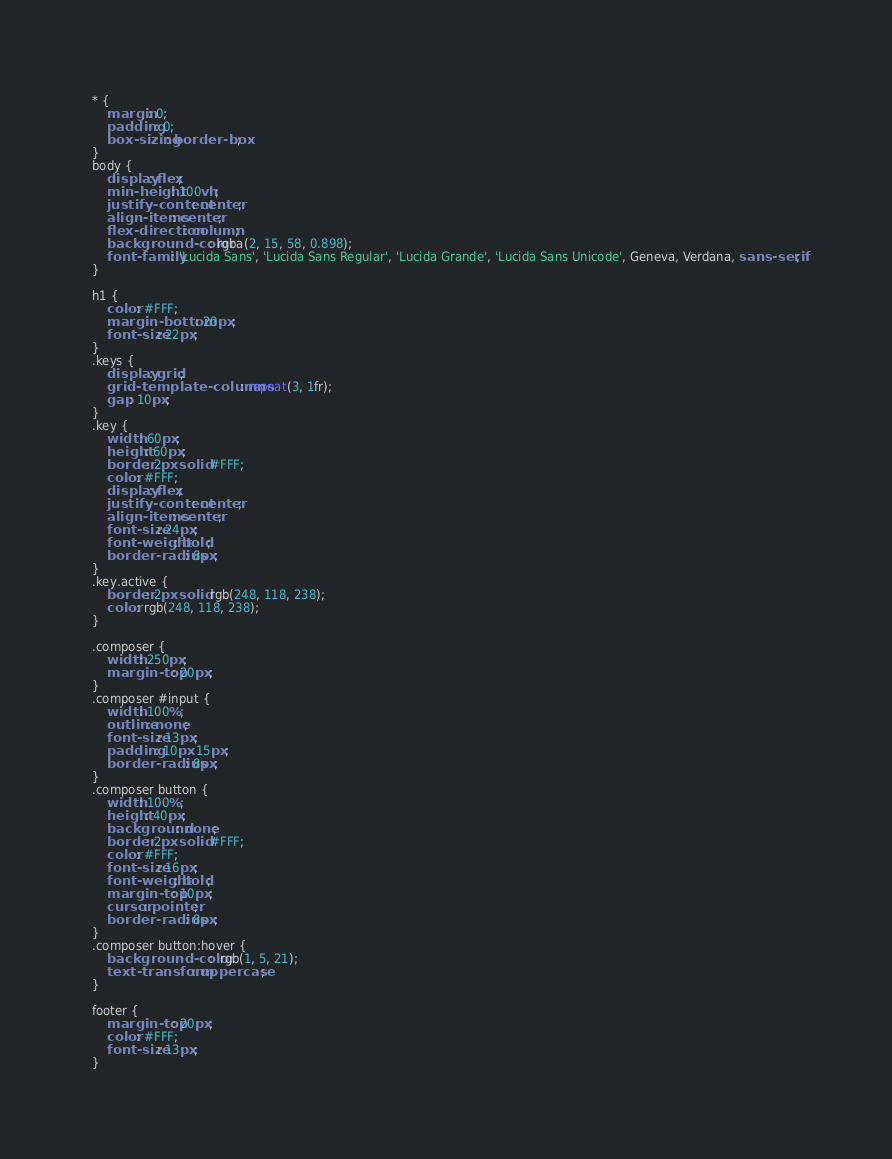Convert code to text. <code><loc_0><loc_0><loc_500><loc_500><_CSS_>* {
    margin: 0;
    padding: 0;
    box-sizing: border-box;
}
body {
    display: flex;
    min-height: 100vh;
    justify-content: center;
    align-items: center;
    flex-direction: column;
    background-color: rgba(2, 15, 58, 0.898);
    font-family: 'Lucida Sans', 'Lucida Sans Regular', 'Lucida Grande', 'Lucida Sans Unicode', Geneva, Verdana, sans-serif;
}

h1 {
    color: #FFF;
    margin-bottom: 20px;
    font-size: 22px;
}
.keys {
    display: grid;
    grid-template-columns: repeat(3, 1fr);
    gap: 10px;
}
.key {
    width: 60px;
    height: 60px;
    border: 2px solid #FFF;
    color: #FFF;
    display: flex;
    justify-content: center;
    align-items: center;
    font-size: 24px;
    font-weight: bold;
    border-radius: 8px;
}
.key.active {
    border: 2px solid rgb(248, 118, 238);
    color: rgb(248, 118, 238);
}

.composer {
    width: 250px;
    margin-top: 20px;
}
.composer #input {
    width: 100%;
    outline: none;
    font-size: 13px;
    padding: 10px 15px;
    border-radius: 8px;
}
.composer button {
    width: 100%;
    height: 40px;
    background: none;
    border: 2px solid #FFF;
    color: #FFF;
    font-size: 16px;
    font-weight: bold;
    margin-top: 10px;
    cursor: pointer;
    border-radius: 8px;
}
.composer button:hover {
    background-color:  rgb(1, 5, 21);
    text-transform: uppercase;
}

footer {
    margin-top: 20px;
    color: #FFF;
    font-size: 13px;
}</code> 